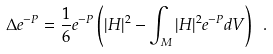Convert formula to latex. <formula><loc_0><loc_0><loc_500><loc_500>\Delta e ^ { - P } = \frac { 1 } { 6 } e ^ { - P } \left ( | H | ^ { 2 } - \int _ { M } | H | ^ { 2 } e ^ { - P } d V \right ) \ .</formula> 